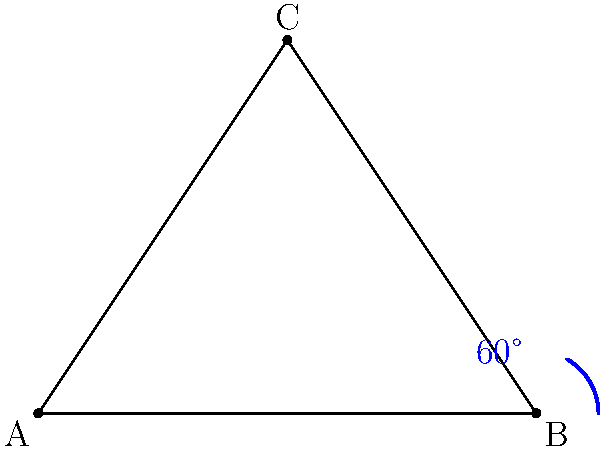In Photoshop, you want to align two elements in your photo composition at a 60-degree angle. Using the image as a reference, which tool would you use to measure and create this angle accurately? To measure and create a 60-degree angle in Photoshop, you would use the Angle Tool. Here's a step-by-step guide:

1. Select the Angle Tool from the toolbar. It might be hidden under the Eyedropper Tool.

2. Click on the point where you want the angle to start (similar to point B in the image).

3. Drag the tool to create the first line of the angle (like B to A in the image).

4. Release the mouse button, then click and drag again to create the second line of the angle (like B to C in the image).

5. As you drag, Photoshop will display the angle measurement in real-time.

6. Release the mouse button when the angle reaches 60 degrees.

7. You can then use this measured angle as a guide to align your photo elements.

The Angle Tool is particularly useful for precise measurements and alignments in photo compositions, allowing you to create balanced and visually appealing layouts without the need for complex calculations.
Answer: Angle Tool 